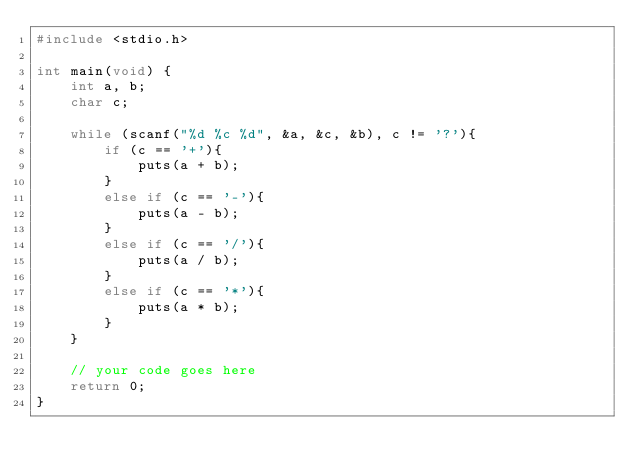<code> <loc_0><loc_0><loc_500><loc_500><_C_>#include <stdio.h>

int main(void) {
	int a, b;
	char c;
	
	while (scanf("%d %c %d", &a, &c, &b), c != '?'){
		if (c == '+'){
			puts(a + b);
		}
		else if (c == '-'){
			puts(a - b);
		}
		else if (c == '/'){
			puts(a / b);
		}
		else if (c == '*'){
			puts(a * b);
		}
	}
	
	// your code goes here
	return 0;
}</code> 